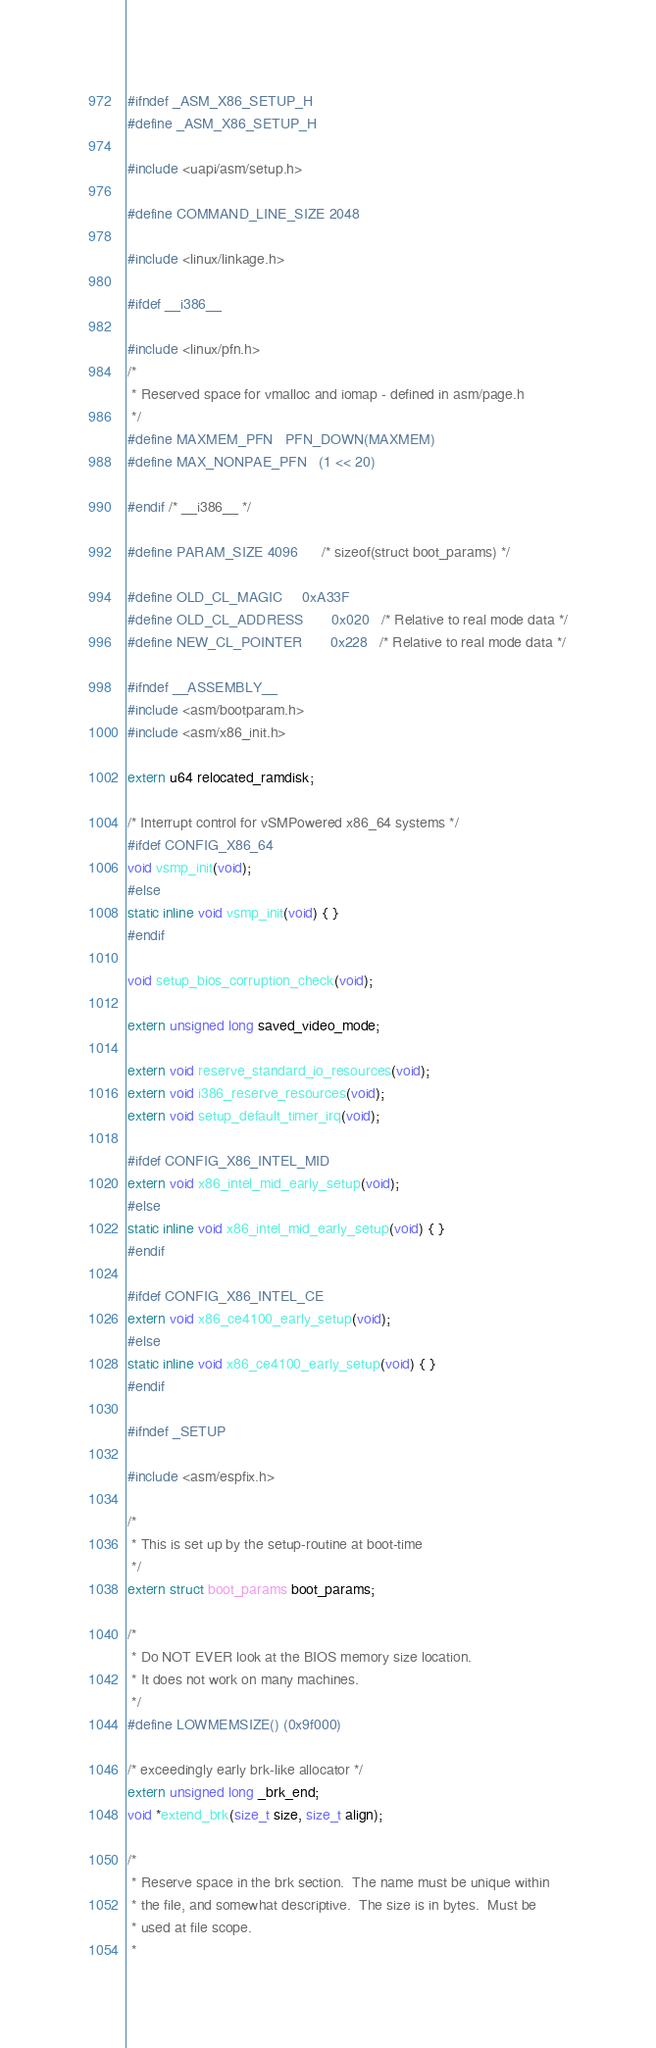<code> <loc_0><loc_0><loc_500><loc_500><_C_>#ifndef _ASM_X86_SETUP_H
#define _ASM_X86_SETUP_H

#include <uapi/asm/setup.h>

#define COMMAND_LINE_SIZE 2048

#include <linux/linkage.h>

#ifdef __i386__

#include <linux/pfn.h>
/*
 * Reserved space for vmalloc and iomap - defined in asm/page.h
 */
#define MAXMEM_PFN	PFN_DOWN(MAXMEM)
#define MAX_NONPAE_PFN	(1 << 20)

#endif /* __i386__ */

#define PARAM_SIZE 4096		/* sizeof(struct boot_params) */

#define OLD_CL_MAGIC		0xA33F
#define OLD_CL_ADDRESS		0x020	/* Relative to real mode data */
#define NEW_CL_POINTER		0x228	/* Relative to real mode data */

#ifndef __ASSEMBLY__
#include <asm/bootparam.h>
#include <asm/x86_init.h>

extern u64 relocated_ramdisk;

/* Interrupt control for vSMPowered x86_64 systems */
#ifdef CONFIG_X86_64
void vsmp_init(void);
#else
static inline void vsmp_init(void) { }
#endif

void setup_bios_corruption_check(void);

extern unsigned long saved_video_mode;

extern void reserve_standard_io_resources(void);
extern void i386_reserve_resources(void);
extern void setup_default_timer_irq(void);

#ifdef CONFIG_X86_INTEL_MID
extern void x86_intel_mid_early_setup(void);
#else
static inline void x86_intel_mid_early_setup(void) { }
#endif

#ifdef CONFIG_X86_INTEL_CE
extern void x86_ce4100_early_setup(void);
#else
static inline void x86_ce4100_early_setup(void) { }
#endif

#ifndef _SETUP

#include <asm/espfix.h>

/*
 * This is set up by the setup-routine at boot-time
 */
extern struct boot_params boot_params;

/*
 * Do NOT EVER look at the BIOS memory size location.
 * It does not work on many machines.
 */
#define LOWMEMSIZE()	(0x9f000)

/* exceedingly early brk-like allocator */
extern unsigned long _brk_end;
void *extend_brk(size_t size, size_t align);

/*
 * Reserve space in the brk section.  The name must be unique within
 * the file, and somewhat descriptive.  The size is in bytes.  Must be
 * used at file scope.
 *</code> 